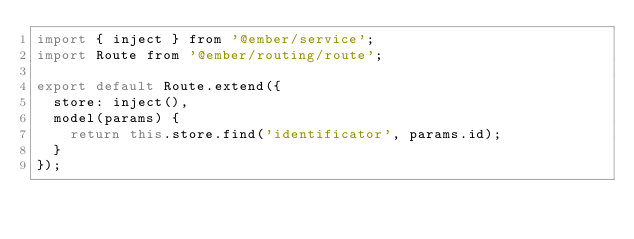Convert code to text. <code><loc_0><loc_0><loc_500><loc_500><_JavaScript_>import { inject } from '@ember/service';
import Route from '@ember/routing/route';

export default Route.extend({
  store: inject(),
  model(params) {
    return this.store.find('identificator', params.id);
  }
});
</code> 